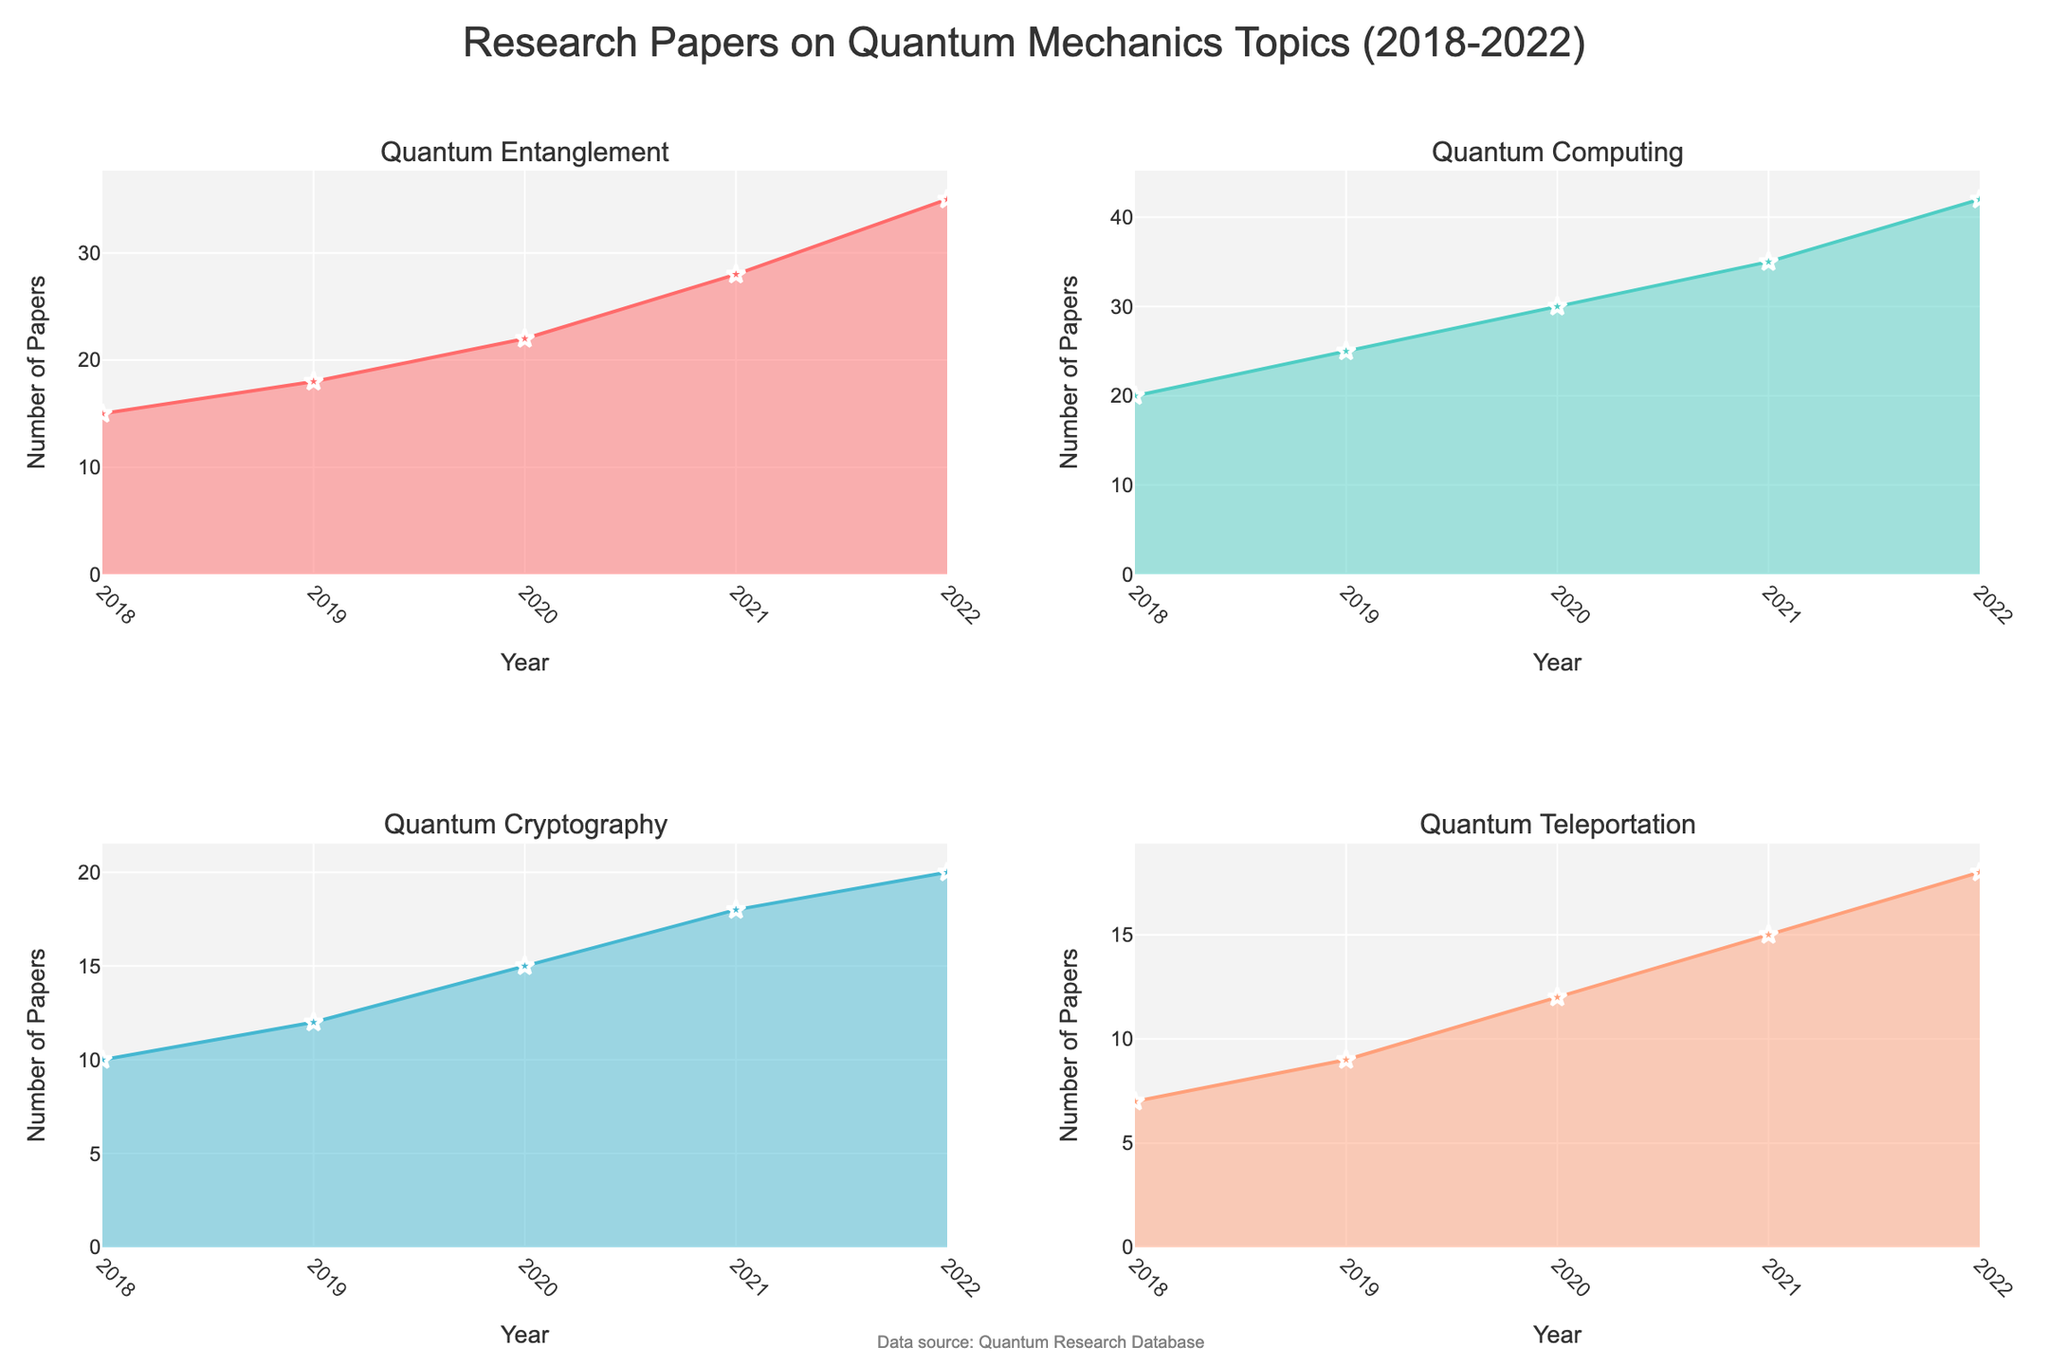What is the title of the figure? The title is typically found at the top of the figure. It gives a summary of what the figure is about. Here, the title is "Research Papers on Quantum Mechanics Topics (2018-2022)."
Answer: Research Papers on Quantum Mechanics Topics (2018-2022) Which subfield had the highest number of papers published in 2020? To find this, look at the area plots for all subfields in the year 2020 and identify the one with the highest point. For 2020, "Quantum Computing" reaches the highest point with 30 papers.
Answer: Quantum Computing How did the number of papers published in "Quantum Teleportation" change from 2019 to 2022? Notice the values at 2019 and 2022 in the area chart for "Quantum Teleportation." In 2019, there were 9 papers, and by 2022, there were 18 papers, indicating an increase.
Answer: Increased by 9 Which year had the highest cumulative number of papers across all subfields? Sum the number of papers for all subfields for each year. The year with the highest total is 2022: (35 + 42 + 20 + 18 = 115).
Answer: 2022 Compare the number of papers published in "Quantum Cryptography" and "Quantum Teleportation" in 2021. Which subfield had more papers? Look at the points for 2021 in the charts for both subfields. "Quantum Cryptography" had 18 papers, while "Quantum Teleportation" had 15.
Answer: Quantum Cryptography What significant trend can you observe in the number of papers published in "Quantum Entanglement" from 2018 to 2022? Observe the chart for "Quantum Entanglement," there is a consistent increasing trend from 15 papers in 2018 to 35 papers in 2022.
Answer: Consistent increase What is the average number of papers published per year in "Quantum Computing" from 2018 to 2022? Sum the numbers for each year and divide by the number of years: (20 + 25 + 30 + 35 + 42) / 5 = 30.4.
Answer: 30.4 Was there any year where "Quantum Entanglement" had fewer publications than "Quantum Cryptography"? Compare the data for each year. In every year from 2018 to 2022, "Quantum Entanglement" had more or equal papers than "Quantum Cryptography."
Answer: No Between "Quantum Computing" and "Quantum Entanglement," which subfield saw a more significant increase in the number of papers from 2018 to 2022? Calculate the difference for each subfield. "Quantum Computing" increased by (42 - 20 = 22), and "Quantum Entanglement" increased by (35 - 15 = 20).
Answer: Quantum Computing What can you infer about research trends in quantum mechanics topics based on the visual data from 2018 to 2022? From the area charts, it can be inferred that research in all subfields is growing over the years, with "Quantum Computing" showing the most pronounced increase.
Answer: Overall growth, especially in Quantum Computing 